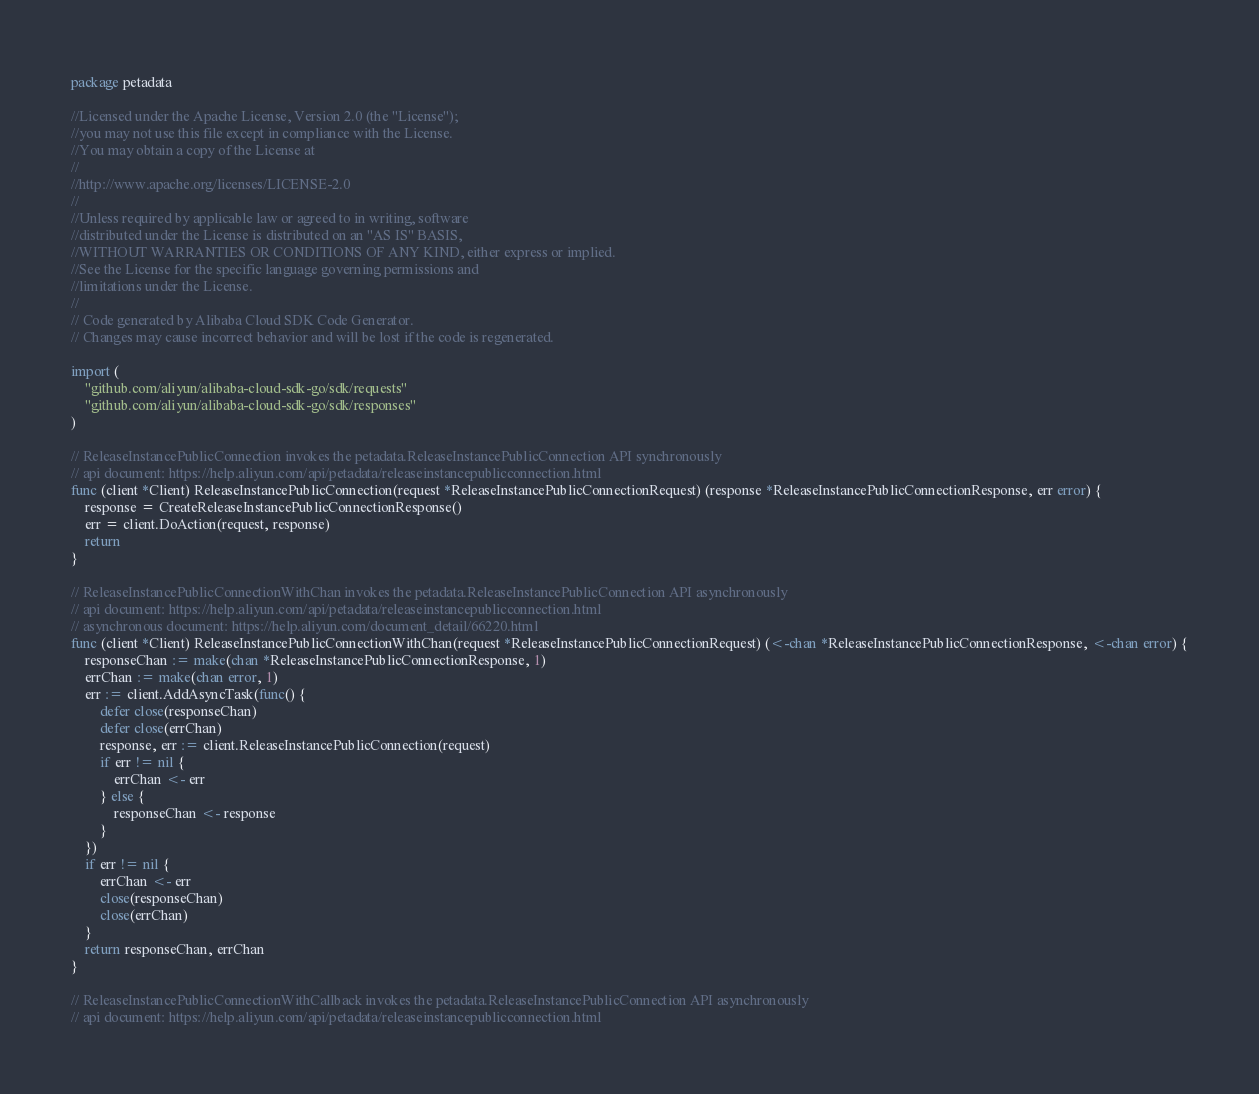Convert code to text. <code><loc_0><loc_0><loc_500><loc_500><_Go_>package petadata

//Licensed under the Apache License, Version 2.0 (the "License");
//you may not use this file except in compliance with the License.
//You may obtain a copy of the License at
//
//http://www.apache.org/licenses/LICENSE-2.0
//
//Unless required by applicable law or agreed to in writing, software
//distributed under the License is distributed on an "AS IS" BASIS,
//WITHOUT WARRANTIES OR CONDITIONS OF ANY KIND, either express or implied.
//See the License for the specific language governing permissions and
//limitations under the License.
//
// Code generated by Alibaba Cloud SDK Code Generator.
// Changes may cause incorrect behavior and will be lost if the code is regenerated.

import (
	"github.com/aliyun/alibaba-cloud-sdk-go/sdk/requests"
	"github.com/aliyun/alibaba-cloud-sdk-go/sdk/responses"
)

// ReleaseInstancePublicConnection invokes the petadata.ReleaseInstancePublicConnection API synchronously
// api document: https://help.aliyun.com/api/petadata/releaseinstancepublicconnection.html
func (client *Client) ReleaseInstancePublicConnection(request *ReleaseInstancePublicConnectionRequest) (response *ReleaseInstancePublicConnectionResponse, err error) {
	response = CreateReleaseInstancePublicConnectionResponse()
	err = client.DoAction(request, response)
	return
}

// ReleaseInstancePublicConnectionWithChan invokes the petadata.ReleaseInstancePublicConnection API asynchronously
// api document: https://help.aliyun.com/api/petadata/releaseinstancepublicconnection.html
// asynchronous document: https://help.aliyun.com/document_detail/66220.html
func (client *Client) ReleaseInstancePublicConnectionWithChan(request *ReleaseInstancePublicConnectionRequest) (<-chan *ReleaseInstancePublicConnectionResponse, <-chan error) {
	responseChan := make(chan *ReleaseInstancePublicConnectionResponse, 1)
	errChan := make(chan error, 1)
	err := client.AddAsyncTask(func() {
		defer close(responseChan)
		defer close(errChan)
		response, err := client.ReleaseInstancePublicConnection(request)
		if err != nil {
			errChan <- err
		} else {
			responseChan <- response
		}
	})
	if err != nil {
		errChan <- err
		close(responseChan)
		close(errChan)
	}
	return responseChan, errChan
}

// ReleaseInstancePublicConnectionWithCallback invokes the petadata.ReleaseInstancePublicConnection API asynchronously
// api document: https://help.aliyun.com/api/petadata/releaseinstancepublicconnection.html</code> 